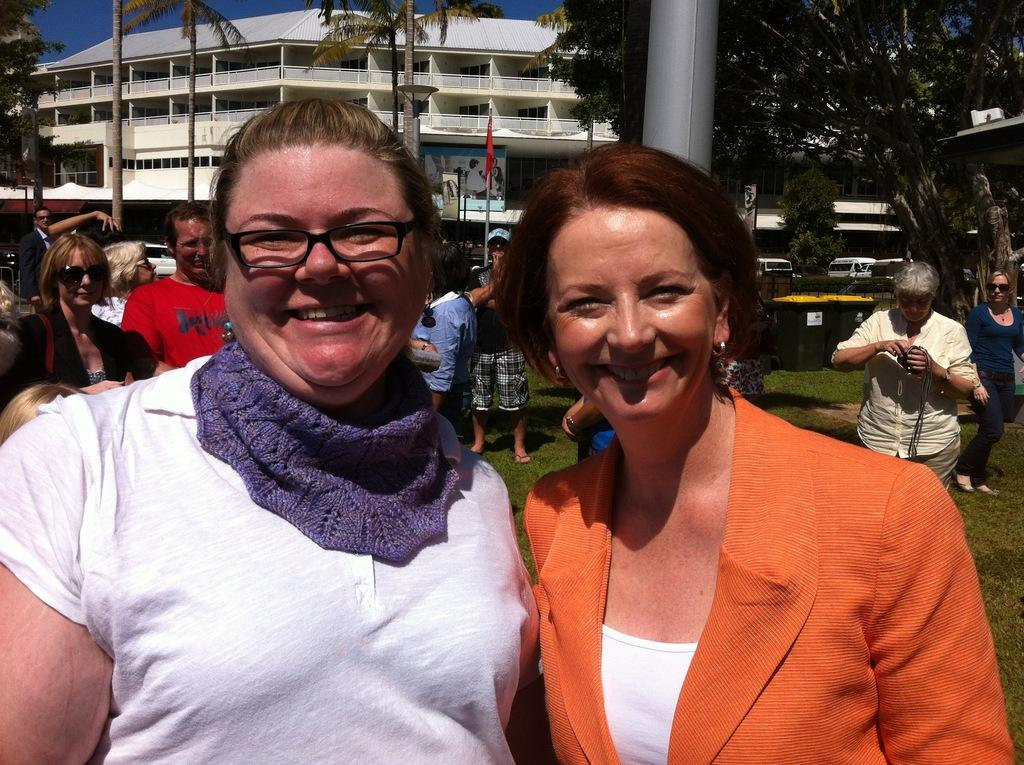What type of structure is visible in the image? There is a building in the image. How many people can be seen in the image? There are many people in the image. What is the ground made of in the image? There is a grassy land in the image. What color is the sky in the image? There is a blue sky in the image. What type of vegetation is present in the image? There are many trees in the image. What type of discussion is taking place among the trees in the image? There is no discussion taking place among the trees in the image; they are stationary vegetation. 